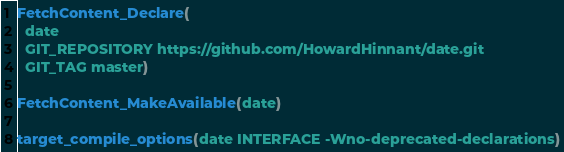Convert code to text. <code><loc_0><loc_0><loc_500><loc_500><_CMake_>
FetchContent_Declare(
  date
  GIT_REPOSITORY https://github.com/HowardHinnant/date.git
  GIT_TAG master)

FetchContent_MakeAvailable(date)

target_compile_options(date INTERFACE -Wno-deprecated-declarations)
</code> 